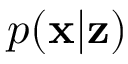Convert formula to latex. <formula><loc_0><loc_0><loc_500><loc_500>p ( x | z )</formula> 